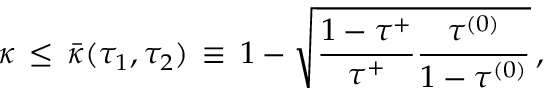<formula> <loc_0><loc_0><loc_500><loc_500>\kappa \, \leq \, \bar { \kappa } ( \tau _ { 1 } , \tau _ { 2 } ) \, \equiv \, 1 - \sqrt { \frac { 1 - \tau ^ { + } } { \tau ^ { + } } \frac { \tau ^ { ( 0 ) } } { 1 - \tau ^ { ( 0 ) } } } \, ,</formula> 